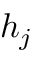<formula> <loc_0><loc_0><loc_500><loc_500>h _ { j }</formula> 